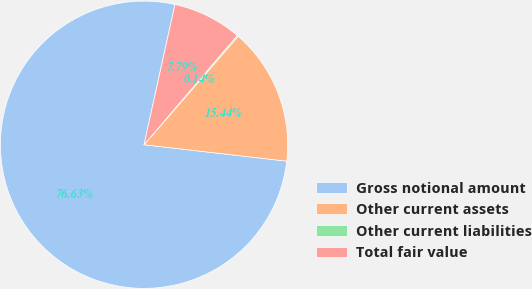Convert chart to OTSL. <chart><loc_0><loc_0><loc_500><loc_500><pie_chart><fcel>Gross notional amount<fcel>Other current assets<fcel>Other current liabilities<fcel>Total fair value<nl><fcel>76.63%<fcel>15.44%<fcel>0.14%<fcel>7.79%<nl></chart> 